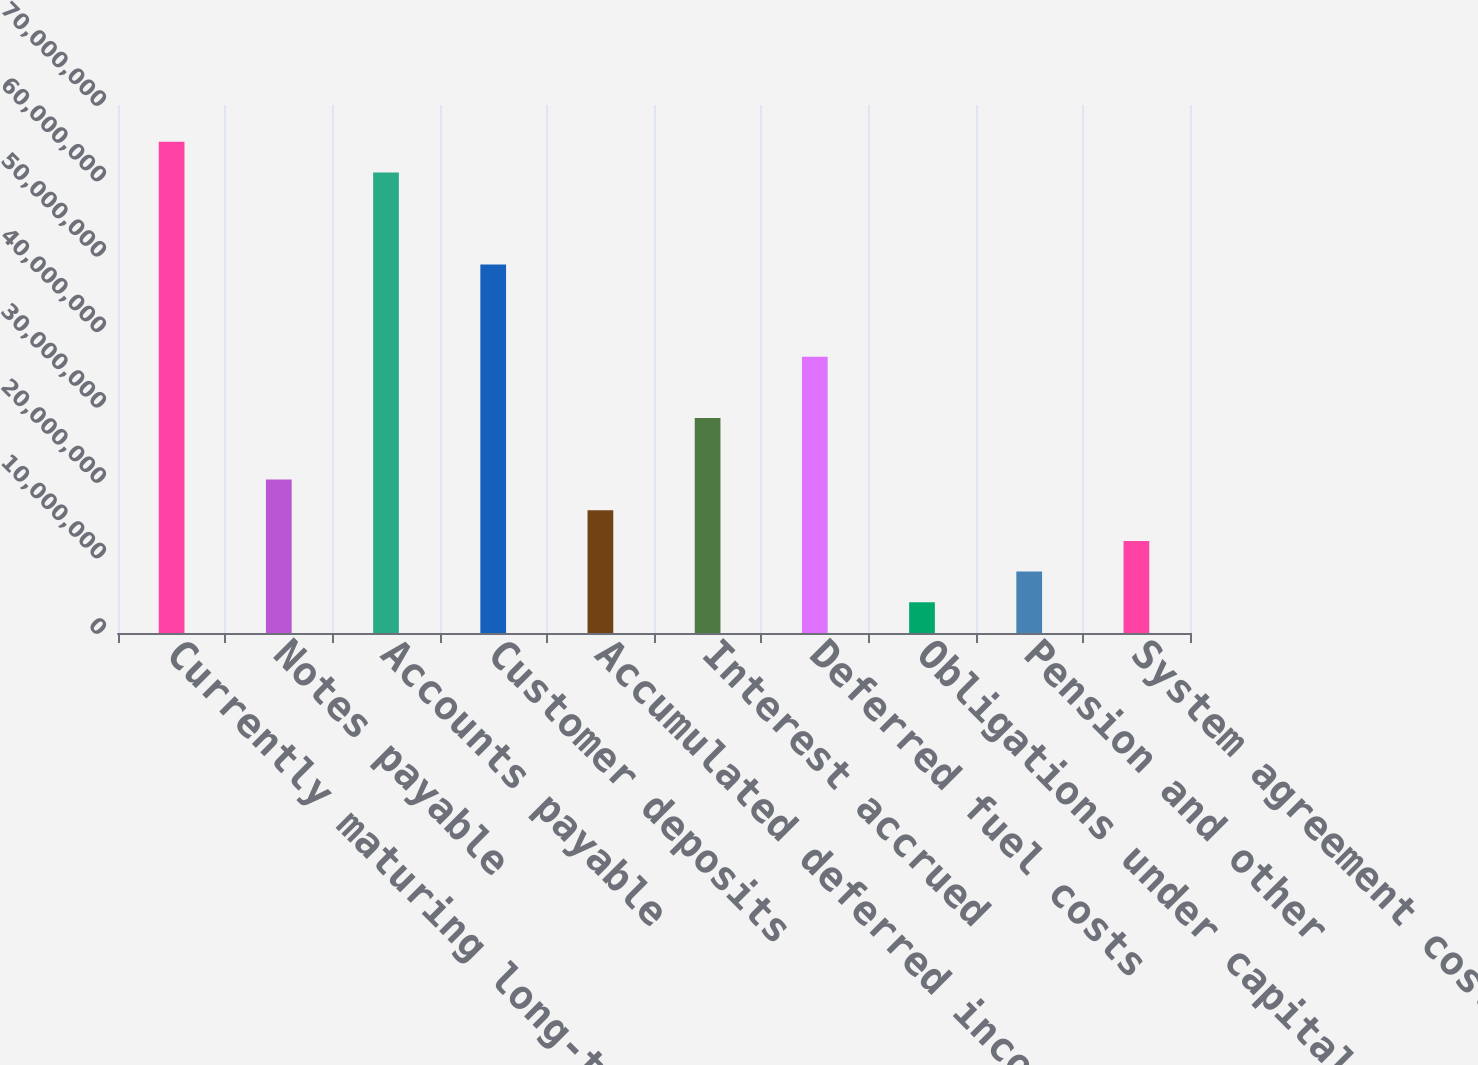Convert chart to OTSL. <chart><loc_0><loc_0><loc_500><loc_500><bar_chart><fcel>Currently maturing long-term<fcel>Notes payable<fcel>Accounts payable<fcel>Customer deposits<fcel>Accumulated deferred income<fcel>Interest accrued<fcel>Deferred fuel costs<fcel>Obligations under capital<fcel>Pension and other<fcel>System agreement cost<nl><fcel>6.51212e+07<fcel>2.03521e+07<fcel>6.10513e+07<fcel>4.88415e+07<fcel>1.62822e+07<fcel>2.8492e+07<fcel>3.66318e+07<fcel>4.07246e+06<fcel>8.14238e+06<fcel>1.22123e+07<nl></chart> 